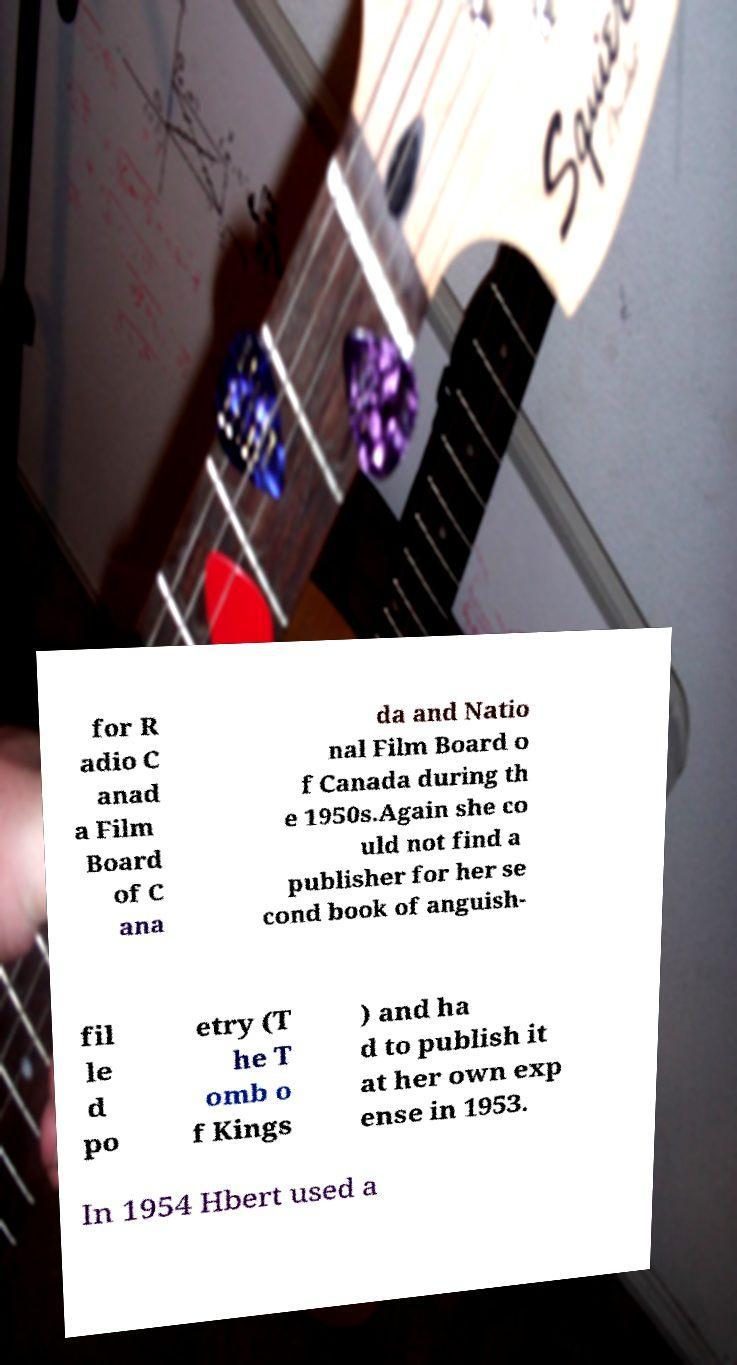I need the written content from this picture converted into text. Can you do that? for R adio C anad a Film Board of C ana da and Natio nal Film Board o f Canada during th e 1950s.Again she co uld not find a publisher for her se cond book of anguish- fil le d po etry (T he T omb o f Kings ) and ha d to publish it at her own exp ense in 1953. In 1954 Hbert used a 